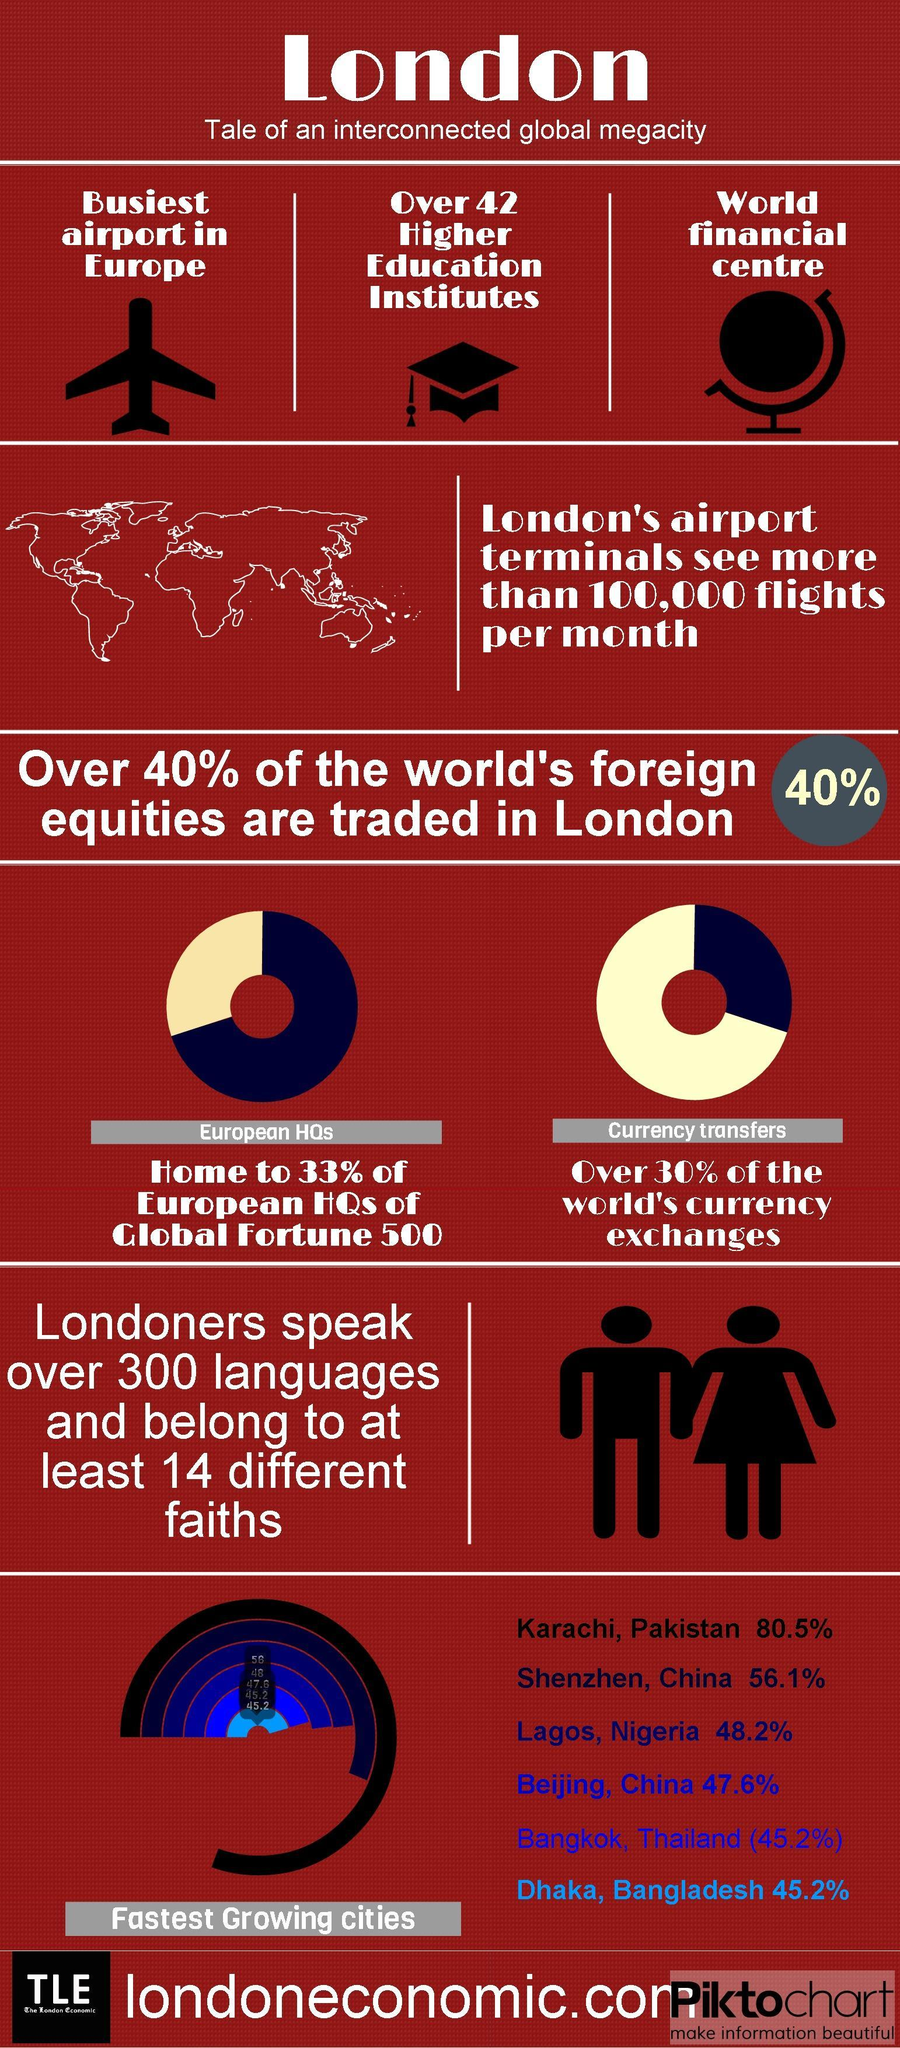How many airplane icons are in this infographic?
Answer the question with a short phrase. 1 Which color is used to represent Karachi- blue, red, black, or white? black What is the percentage of the world's currency exchanges outside London? 70% What is the percentage of European headquarters outside London? 67% What is the third fastest-growing city in the world? Lagos, Nigeria What is the percentage of the world's foreign equity traded outside London? 60% 